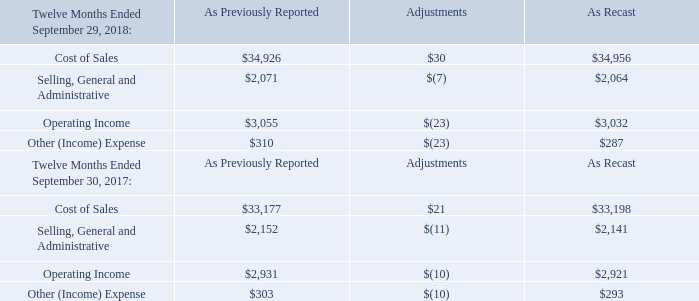In November 2016, the FASB issued guidance that requires entities to show the changes in the total of cash, cash equivalents, restricted cash and restricted cash equivalents in the statement of cash flows. The guidance is effective for annual reporting periods and interim periods within those annual reporting periods beginning after December 15, 2017, our fiscal 2019. The retrospective transition method should be applied. We adopted this guidance in the first quarter of fiscal 2019 and it did not have a material impact on our consolidated financial statements.
In October 2016, the FASB issued guidance that requires companies to recognize the income tax effects of intercompany sales and transfers of assets, other than
inventory, in the period in which the transfer occurs. The guidance is effective for annual reporting periods and interim periods within those annual reporting
periods beginning after December 15, 2017, our fiscal 2019. The modified retrospective transition method should be applied. We adopted this guidance in the first
quarter of fiscal 2019 and it did not have a material impact on our consolidated financial statements.
In August 2016, the FASB issued guidance that aims to eliminate diversity in practice in how certain cash receipts and cash payments are presented and classified in the statement of cash flows. The guidance is effective for annual reporting periods and interim periods within those annual reporting periods beginning after December 15, 2017, our fiscal 2019. The retrospective transition method should be applied. We adopted this guidance in the first quarter of fiscal 2019 and it did not have a material impact on our consolidated financial statements.
n January 2016, the FASB issued guidance that requires most equity investments be measured at fair value, with subsequent other changes in fair value recognized in net income. The guidance also impacts financial liabilities under the fair value option and the presentation and disclosure requirements on the classification and measurement of financial instruments. The guidance is effective for annual reporting periods and interim periods within those annual reporting periods beginning after December 15, 2017, our fiscal 2019. It should be applied by means of a cumulative-effect adjustment to the balance sheet as of the beginning of the fiscal year of adoption, unless equity securities do not have readily determinable fair values, in which case the amendments should be applied prospectively. We adopted this guidance in the first quarter of fiscal 2019. We did not use prospective amendments for any investments and adoption did not have a material impact on our consolidated financial statements.
The following reconciliations provide the effect of the reclassification of the net periodic benefit cost from operating expenses to other (income) expense in our consolidated statements of income for fiscal year 2018 and 2017 (in millions):
Did the adoption of the new FASB issued guidances have a material impact on the firm's consolidated financial statements?  No. What guidance did the FASB issue in November 2016? In november 2016, the fasb issued guidance that requires entities to show the changes in the total of cash, cash equivalents, restricted cash and restricted cash equivalents in the statement of cash flows. What guidance did the FASB issue in August 2016? In august 2016, the fasb issued guidance that aims to eliminate diversity in practice in how certain cash receipts and cash payments are presented and classified in the statement of cash flows. What is the percentage change between the cost of sales previously reported in 2017 and 2018?
Answer scale should be: percent. ($34,926-$33,177)/$33,177
Answer: 5.27. What is the  percentage change between the cost of sales as recasted in 2017 and 2018?
Answer scale should be: percent. ($34,956-$33,198)/$33,198
Answer: 5.3. What is the difference between the operating income as recasted in 2017 and 2018?
Answer scale should be: percent. ($3,032-$2,921)/$2,921
Answer: 3.8. 